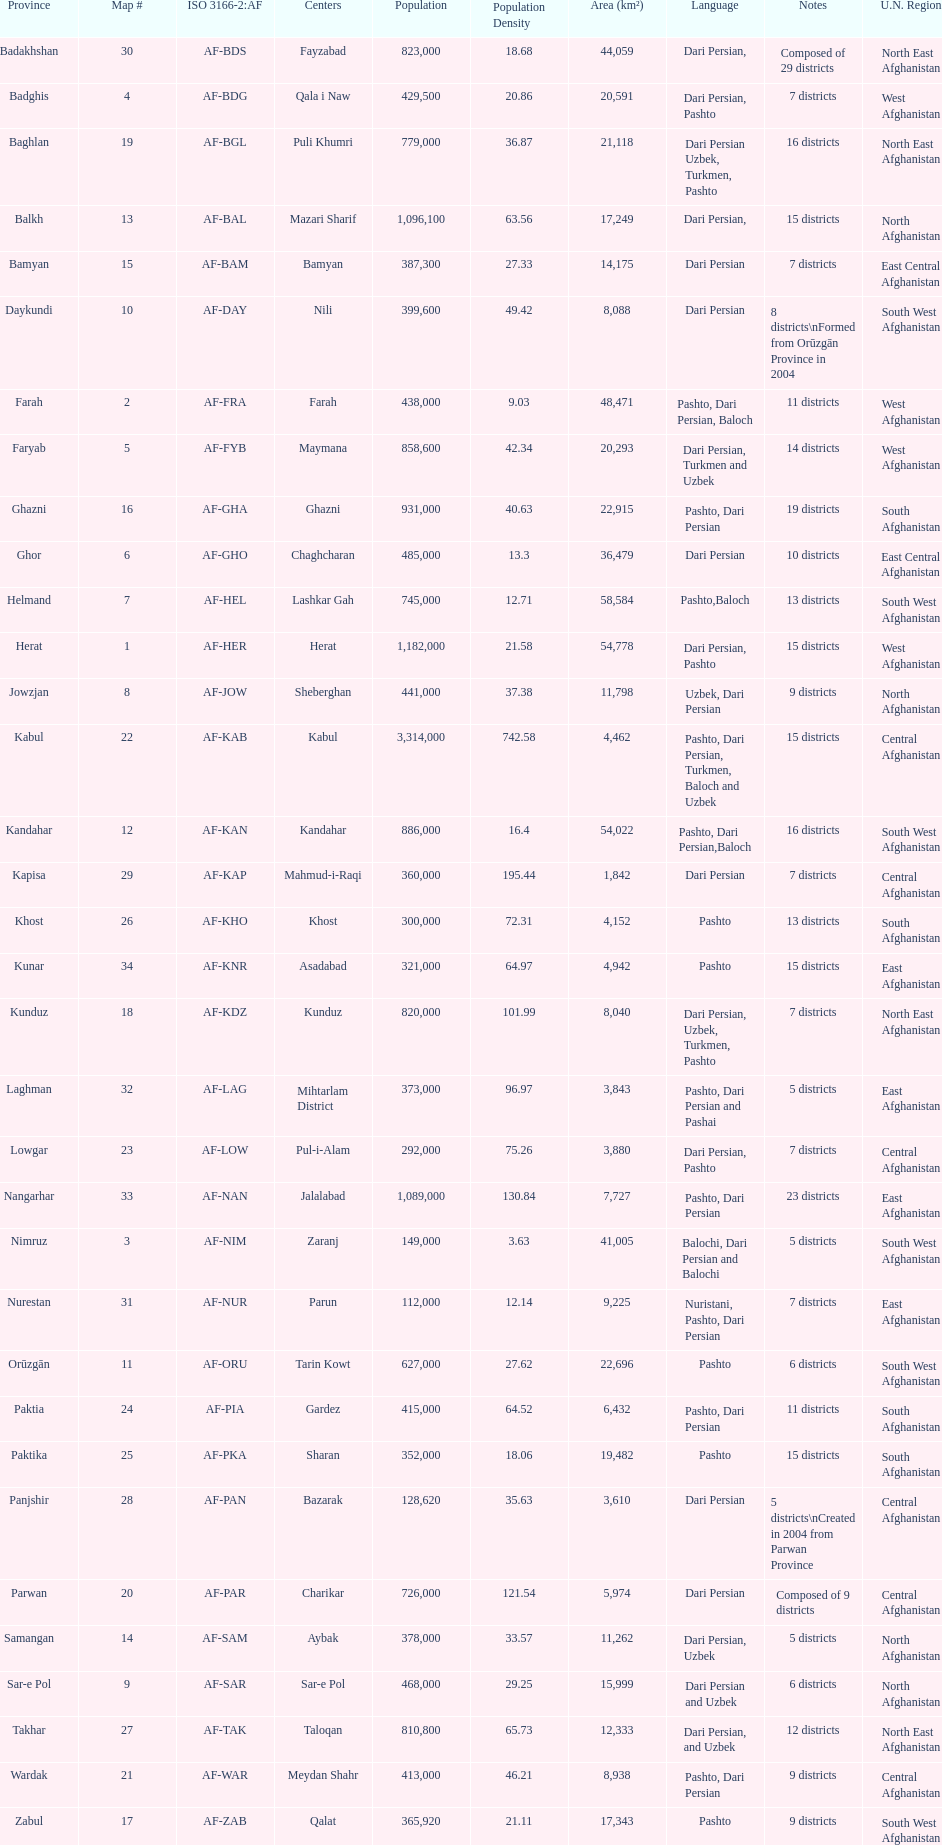Does ghor or farah possess more districts? Farah. 